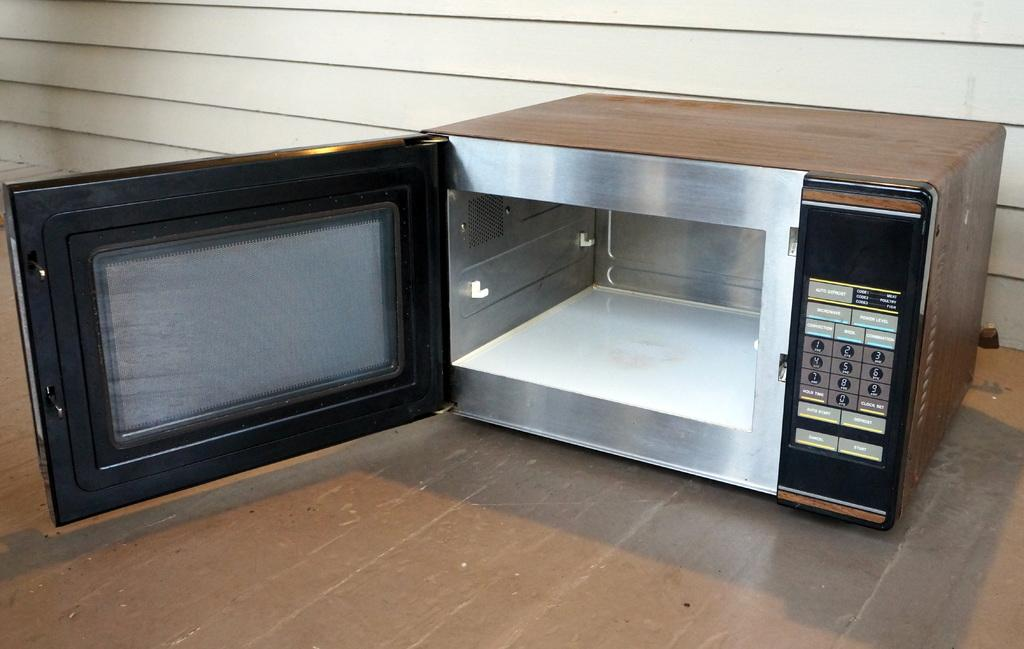What type of appliance is present in the image? There is an oven in the image. Where is the oven located in the image? The oven is on the floor. What can be seen in the background of the image? There is a wall in the background of the image. What type of spy equipment can be seen on the oven in the image? There is no spy equipment present on the oven in the image. 